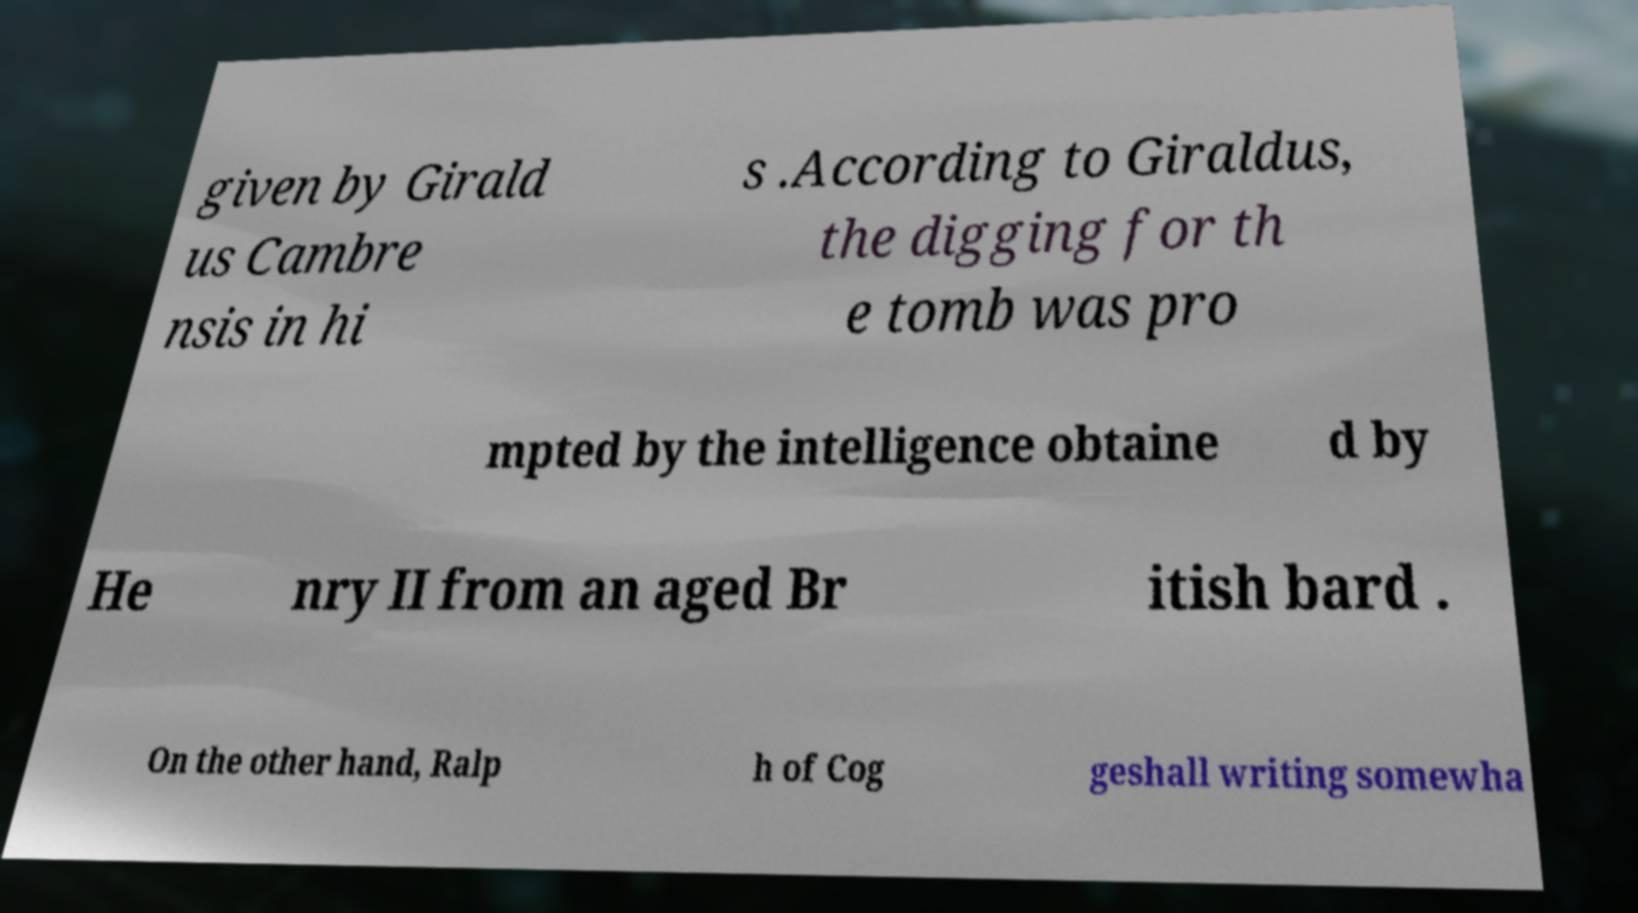Please read and relay the text visible in this image. What does it say? given by Girald us Cambre nsis in hi s .According to Giraldus, the digging for th e tomb was pro mpted by the intelligence obtaine d by He nry II from an aged Br itish bard . On the other hand, Ralp h of Cog geshall writing somewha 